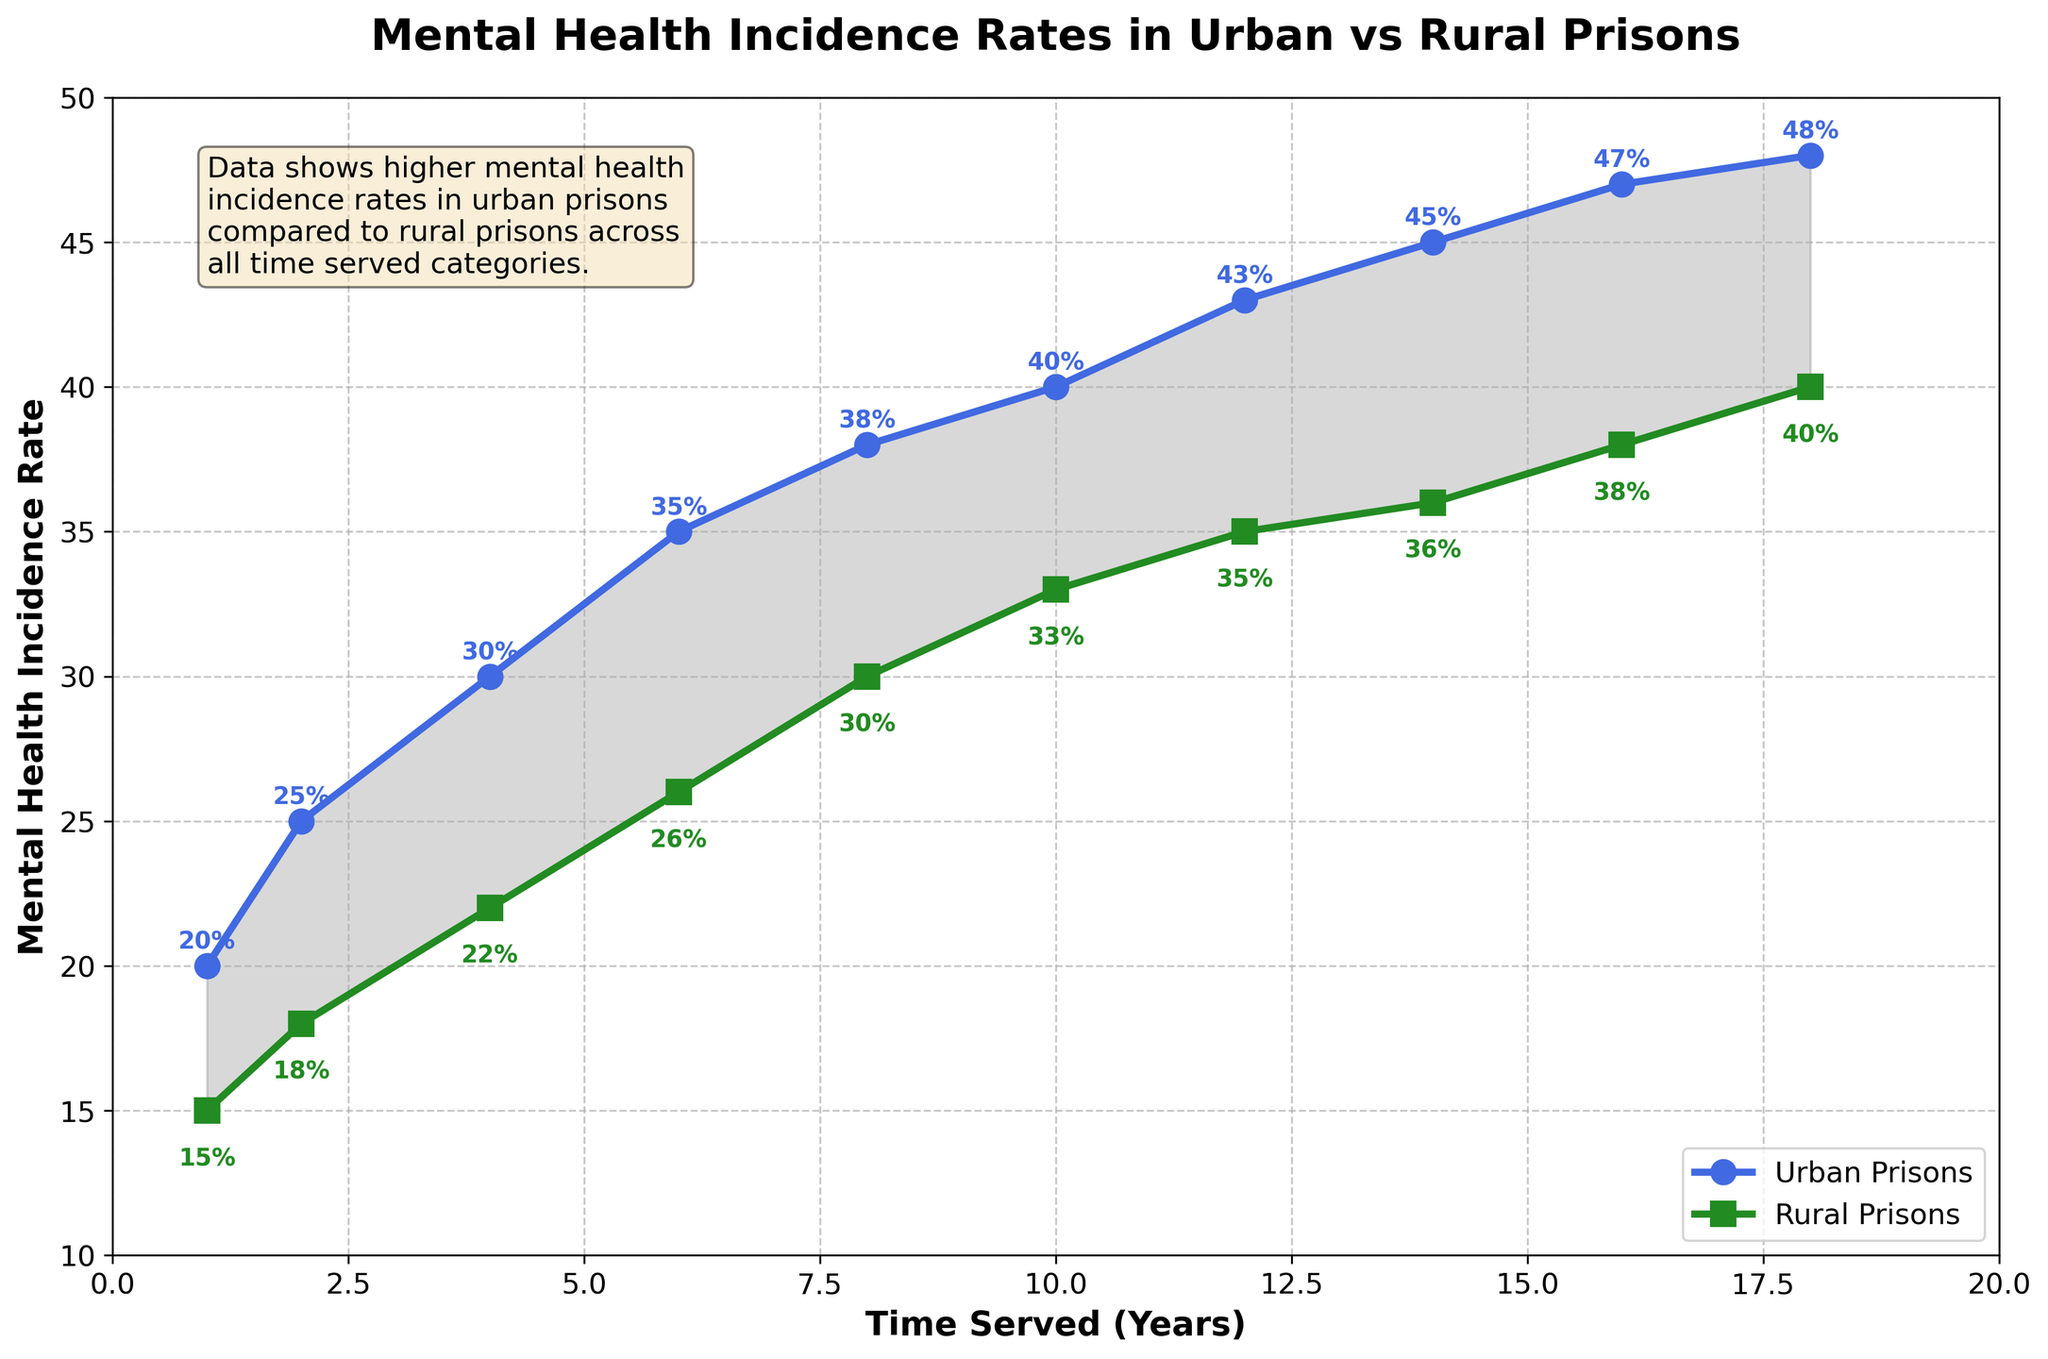What is the title of the plot? The title is displayed at the top of the plot. It reads "Mental Health Incidence Rates in Urban vs Rural Prisons."
Answer: Mental Health Incidence Rates in Urban vs Rural Prisons What are the labels on the x-axis and y-axis? The x-axis is labeled "Time Served (Years)", while the y-axis is labeled "Mental Health Incidence Rate."
Answer: Time Served (Years), Mental Health Incidence Rate How high is the mental health incidence rate in urban prisons for inmates who have served 10-12 years? To find this, locate the point on the urban line (indicated in blue) at 10-12 years and read the corresponding y-value. The label shows 40%.
Answer: 40% Is the mental health incidence rate higher in urban or rural prisons after 8-10 years served? By comparing the incidence rates at the 8-10 years point for both urban (blue line) and rural (green line) prisons, the urban prison rate is 38%, whereas the rural prison rate is 30%, making urban higher.
Answer: Urban Which location shows a higher rate increase between 4-6 and 6-8 years served, and by how much? The urban prison rate increases from 30% to 35%, a 5% increase. The rural prison rate increases from 22% to 26%, a 4% increase. Thus, urban prisons show a higher rate increase by 1%.
Answer: Urban, 1% What is the difference in mental health incidence rates between urban and rural prisons for inmates serving 12-14 years? The urban incidence rate at 12-14 years is 43%, while the rural rate is 35%. The difference is 43% - 35% = 8%.
Answer: 8% On average, what is the mental health incidence rate for inmates in rural prisons? Sum the incidence rates for all time periods in rural prisons (15 + 18 + 22 + 26 + 30 + 33 + 35 + 36 + 38 + 40 = 293) and divide by the number of periods (10). The average is 293 / 10 = 29.3%.
Answer: 29.3% Does the plot suggest that inmates in urban prisons generally have higher mental health incidence rates compared to those in rural prisons? The urban line is consistently above the rural line across all time periods, which indicates higher incidence rates in urban prisons.
Answer: Yes Identify one example of a specific time period where the mental health incidence rate is annotated for urban prisons. For instance, at the 1-2 years mark, the rate is annotated as 20%.
Answer: 1-2 years (20%) Are there any visible trends in mental health incidence rates over time for both urban and rural prisons? Both lines show an upward trend, indicating that mental health incidence rates increase with time served in both urban and rural prisons.
Answer: Increasing trend 